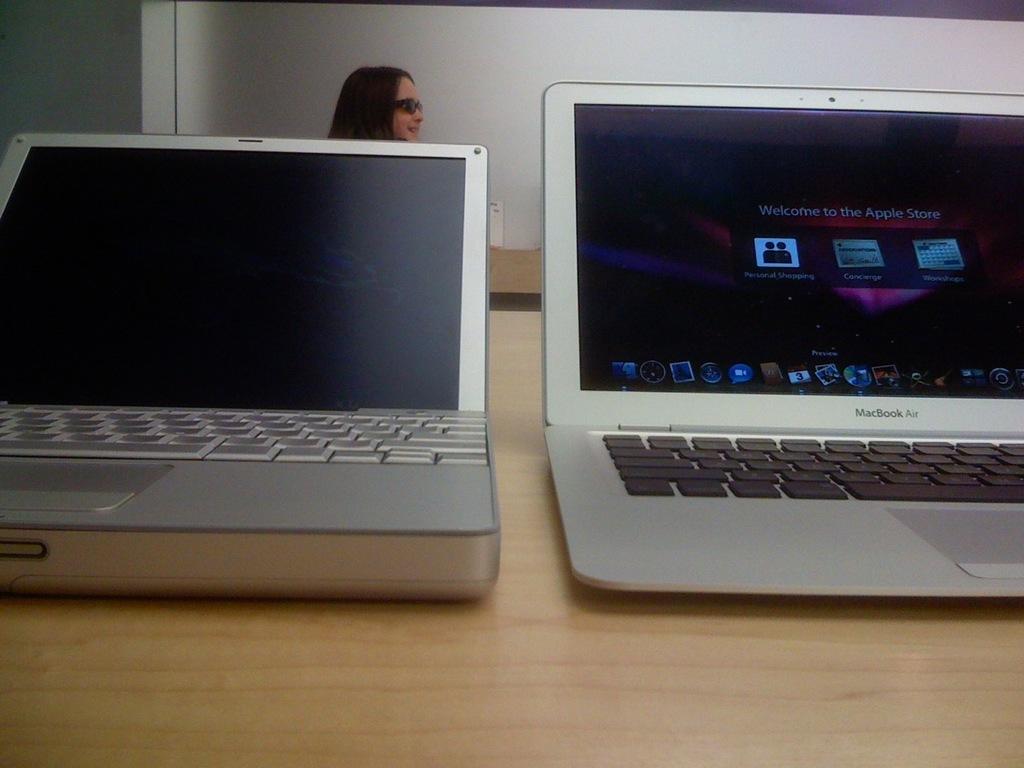What brand of laptop is this on the right?
Provide a succinct answer. Macbook. What does the macbook say welcome too on the right?
Make the answer very short. Apple store. 